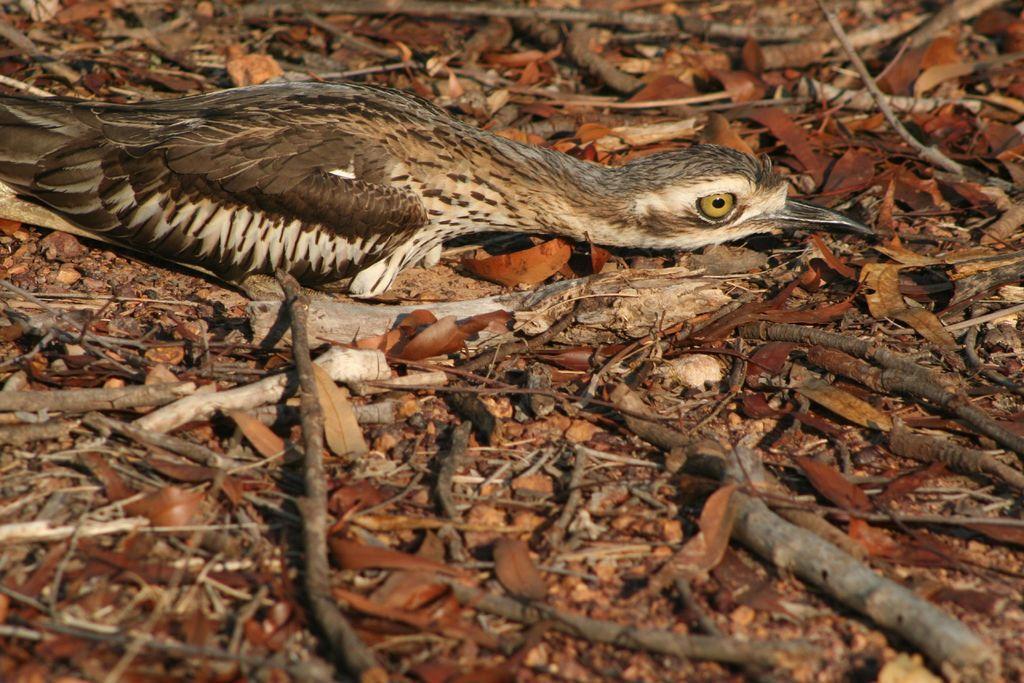In one or two sentences, can you explain what this image depicts? In this image I can see the ground, few leaves on the ground, few wooden sticks and a bird which is brown, cream and black in color on the surface of the ground. 